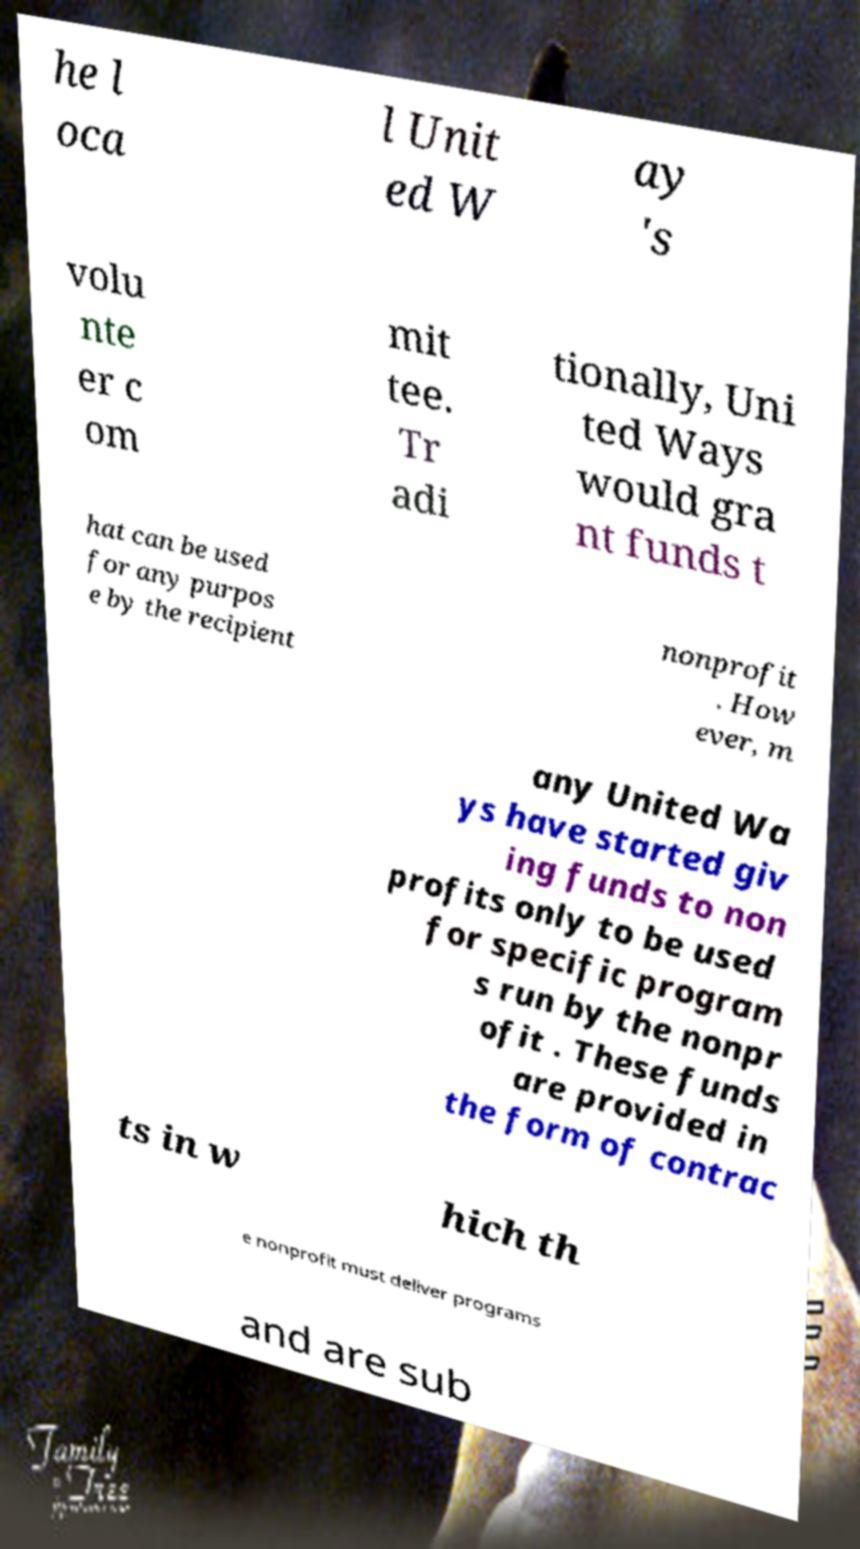I need the written content from this picture converted into text. Can you do that? he l oca l Unit ed W ay 's volu nte er c om mit tee. Tr adi tionally, Uni ted Ways would gra nt funds t hat can be used for any purpos e by the recipient nonprofit . How ever, m any United Wa ys have started giv ing funds to non profits only to be used for specific program s run by the nonpr ofit . These funds are provided in the form of contrac ts in w hich th e nonprofit must deliver programs and are sub 